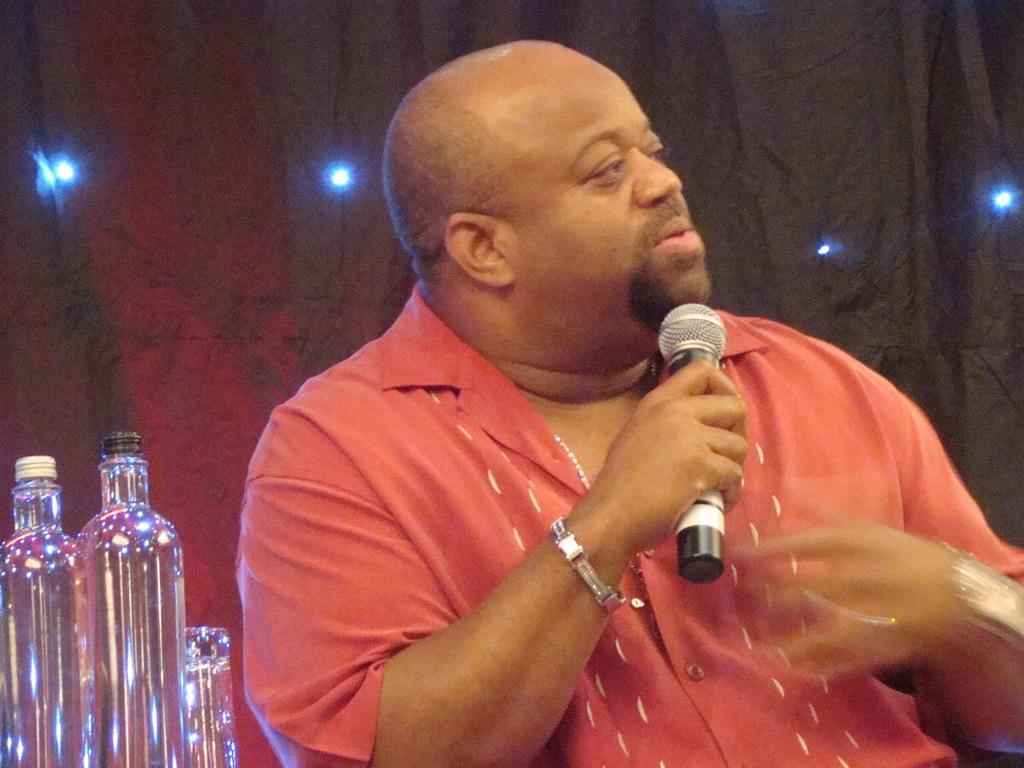Can you describe this image briefly? In this image i can see a person holding a microphone and few glass bottles beside him. 